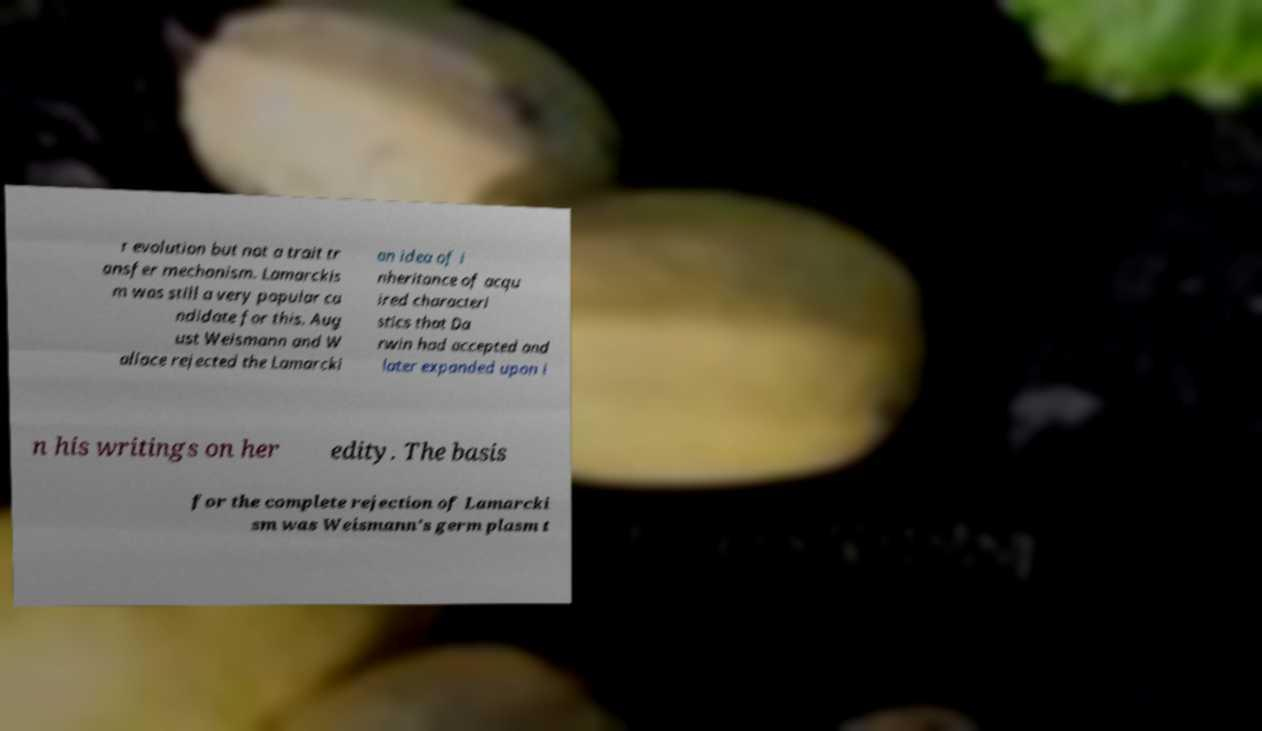For documentation purposes, I need the text within this image transcribed. Could you provide that? r evolution but not a trait tr ansfer mechanism. Lamarckis m was still a very popular ca ndidate for this. Aug ust Weismann and W allace rejected the Lamarcki an idea of i nheritance of acqu ired characteri stics that Da rwin had accepted and later expanded upon i n his writings on her edity. The basis for the complete rejection of Lamarcki sm was Weismann's germ plasm t 